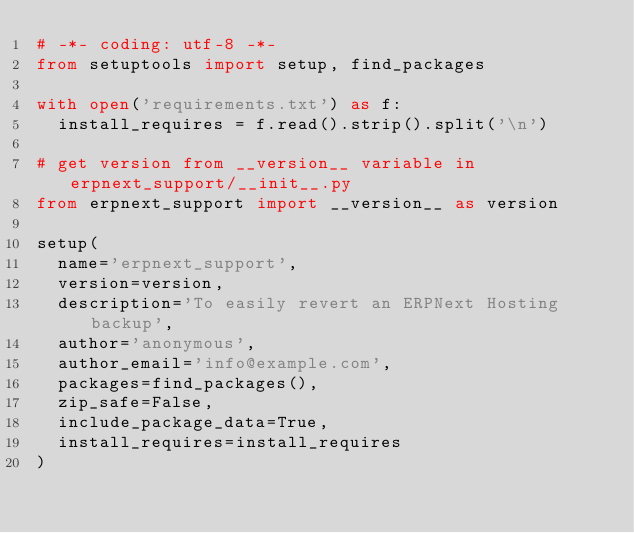<code> <loc_0><loc_0><loc_500><loc_500><_Python_># -*- coding: utf-8 -*-
from setuptools import setup, find_packages

with open('requirements.txt') as f:
	install_requires = f.read().strip().split('\n')

# get version from __version__ variable in erpnext_support/__init__.py
from erpnext_support import __version__ as version

setup(
	name='erpnext_support',
	version=version,
	description='To easily revert an ERPNext Hosting backup',
	author='anonymous',
	author_email='info@example.com',
	packages=find_packages(),
	zip_safe=False,
	include_package_data=True,
	install_requires=install_requires
)
</code> 